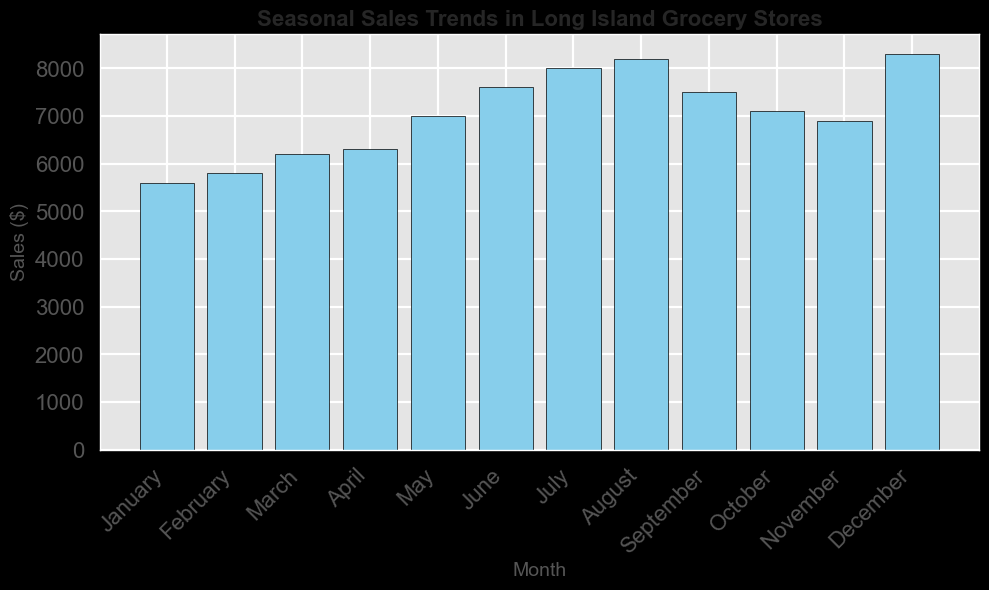What's the month with the highest sales? To find the month with the highest sales, look at the tallest bar in the histogram, which corresponds to December with a sales value of $8300.
Answer: December What's the difference in sales between July and August? For July, the sales are $8000, and for August, they are $8200. The difference is $8200 - $8000 = $200.
Answer: $200 What is the average sales for the first quarter (January, February, March)? Summing the sales for January ($5600), February ($5800), and March ($6200) gives $17600. The average is $17600 / 3 = $5867.
Answer: $5867 Which month records the lowest sales, and what is the value? The shortest bar indicates the lowest sales, occurring in January with a sales value of $5600.
Answer: January, $5600 How do the sales in May compare with the sales in November? The sales in May are $7000, while in November, they are $6900. May's sales are higher by $7000 - $6900 = $100.
Answer: May is $100 higher What is the total sales revenue for the summer months (June, July, August)? The sales for June, July, and August are $7600, $8000, and $8200 respectively. The total sales revenue is $7600 + $8000 + $8200 = $23800.
Answer: $23800 What's the percent increase in sales from January to December? January sales are $5600, and December sales are $8300. The increase is $8300 - $5600 = $2700. The percent increase is ($2700 / $5600) * 100 = 48.2%.
Answer: 48.2% How does the height of the bar in October compare to that in September? The bar for October reflects $7100 in sales, while the bar for September shows $7500 in sales. October’s bar is shorter by $7500 - $7100 = $400.
Answer: Shorter by $400 Which month has seen an increase in sales compared to the previous month, yet shows the smallest difference? Comparing consecutive months, February shows the smallest increase over January by $5800 - $5600 = $200.
Answer: February, $200 